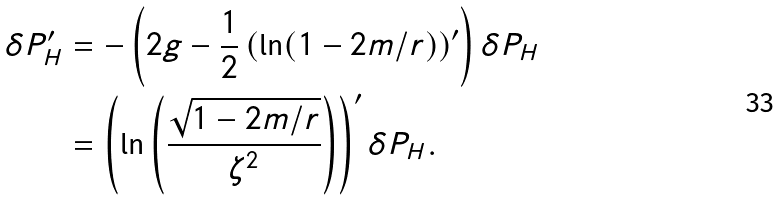<formula> <loc_0><loc_0><loc_500><loc_500>\delta P _ { H } ^ { \prime } & = - \left ( 2 g - \frac { 1 } { 2 } \left ( \ln ( 1 - 2 m / r ) \right ) ^ { \prime } \right ) \delta P _ { H } \\ & = \left ( \ln \left ( \frac { \sqrt { 1 - 2 m / r } } { \zeta ^ { 2 } } \right ) \right ) ^ { \prime } \delta P _ { H } .</formula> 